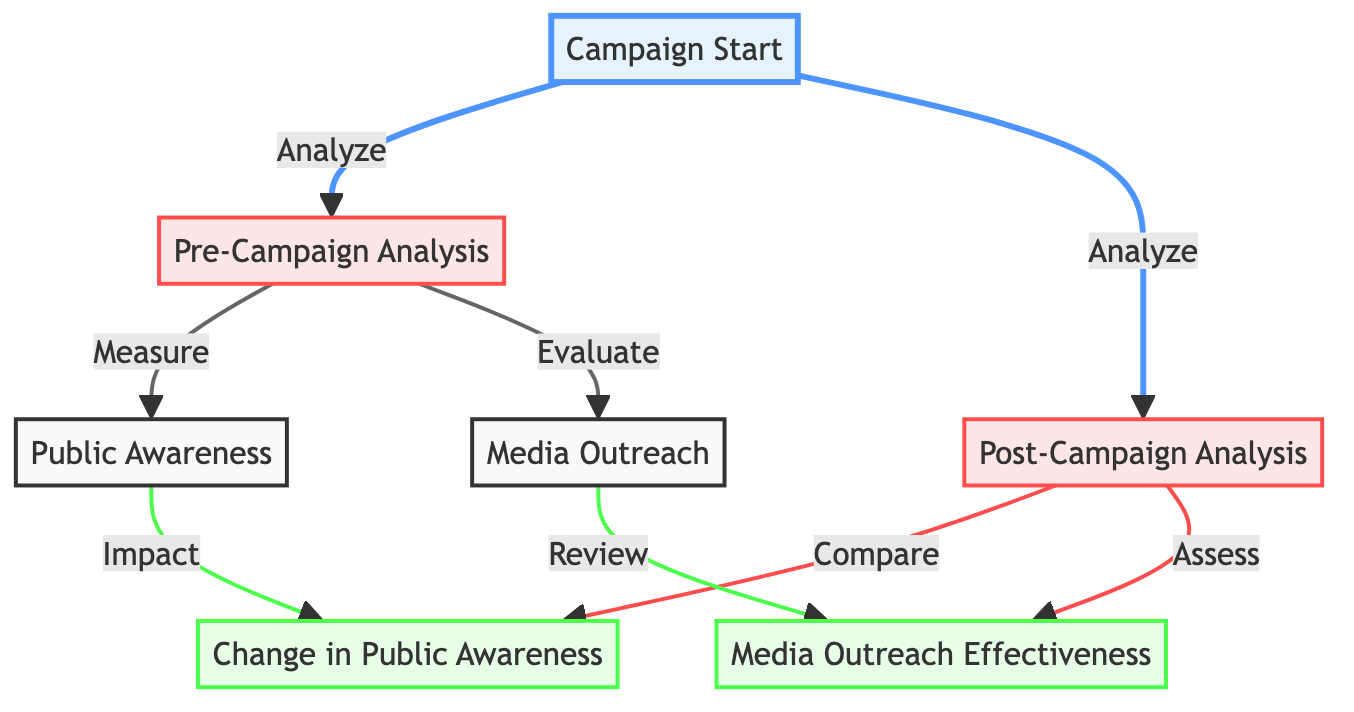what is the first node in the diagram? The first node is labeled "Campaign Start," which is represented at the beginning of the flowchart.
Answer: Campaign Start how many analysis nodes are present in the diagram? There are two analysis nodes: "Pre-Campaign Analysis" and "Post-Campaign Analysis."
Answer: 2 what is the relationship between "Public Awareness" and "Change in Public Awareness"? The relationship is that "Public Awareness" impacts "Change in Public Awareness," indicating that the measurement of public awareness affects the outcome after the campaign.
Answer: Impact which node is connected to "Media Outreach" by a review process? The node connected to "Media Outreach" by a review process is "Media Outreach Effectiveness."
Answer: Media Outreach Effectiveness what happens after the "Post-Campaign Analysis"? After the "Post-Campaign Analysis," the next steps are "Change in Public Awareness" and "Media Outreach Effectiveness," both of which are assessed based on the analysis.
Answer: Change in Public Awareness and Media Outreach Effectiveness explain the flow between "Campaign Start" and "Public Awareness." The flow starts at "Campaign Start," which leads to "Pre-Campaign Analysis." From "Pre-Campaign Analysis," there is a measurement process that moves towards "Public Awareness."
Answer: Analyze to Pre-Campaign Analysis to Measure to Public Awareness what connects “Media Outreach” to “Media Outreach Effectiveness”? "Media Outreach" is connected to "Media Outreach Effectiveness" through a reviewing process, indicating the assessment of outreach effectiveness based on initial media outreach efforts.
Answer: Review how does “Change in Public Awareness” relate to “Awareness Change”? "Change in Public Awareness" is the output that evaluates the impact of pre-campaign public awareness after campaigns conclude in relation to awareness metrics.
Answer: Compare what are the two evaluation processes initiated by “Post-Campaign Analysis”? The two evaluation processes initiated by "Post-Campaign Analysis" are to compare "Change in Public Awareness" and assess "Media Outreach Effectiveness."
Answer: Compare and Assess 